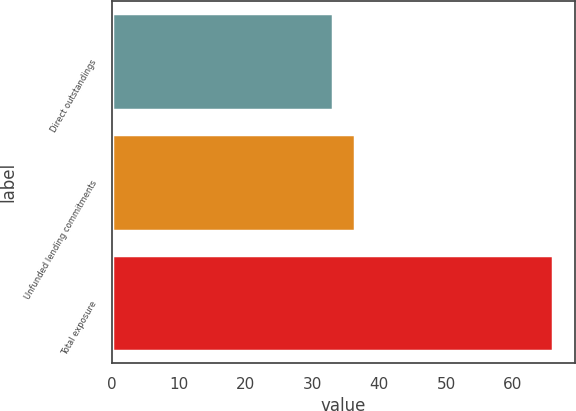Convert chart. <chart><loc_0><loc_0><loc_500><loc_500><bar_chart><fcel>Direct outstandings<fcel>Unfunded lending commitments<fcel>Total exposure<nl><fcel>33<fcel>36.3<fcel>66<nl></chart> 